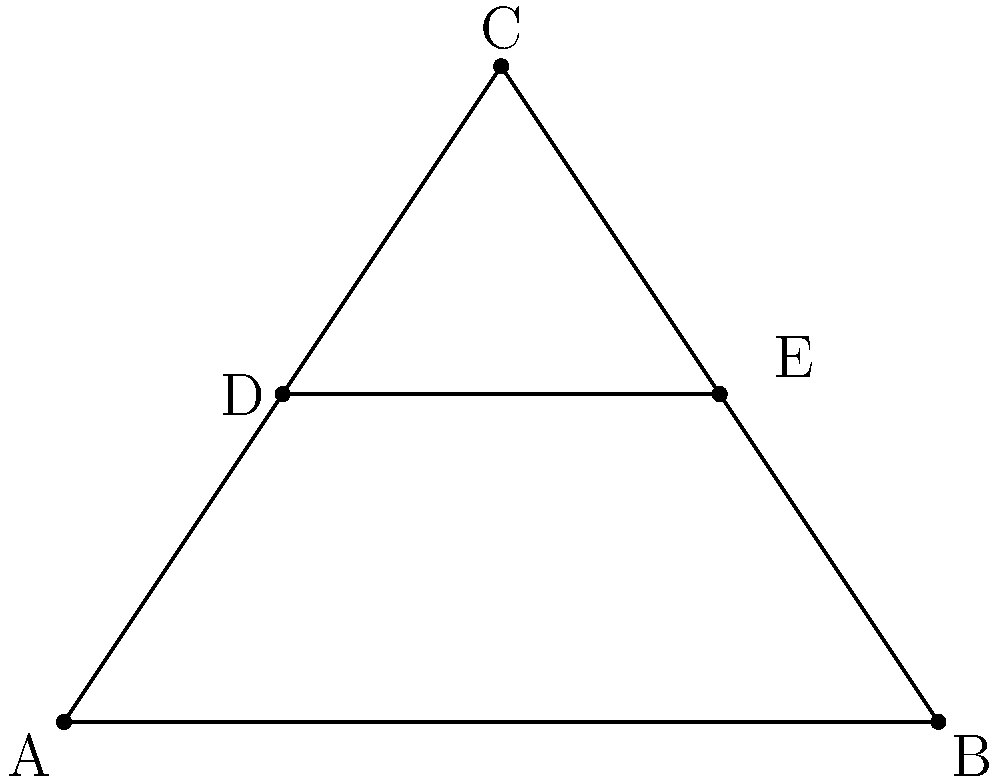In a fashion shoot, you're capturing a model wearing layered necklaces that form geometric patterns on her neckline. The necklaces create a triangle ABC with a straight line DE across it, as shown in the diagram. If the area of triangle ADE is 1.5 square inches and the area of triangle BDE is 2.25 square inches, what is the ratio of the length of AD to DB? Let's approach this step-by-step:

1) First, we know that the ratio of the areas of two triangles with the same height is equal to the ratio of their bases. In this case, the height is the perpendicular distance from point E to line AB.

2) Let's call the length of AD as x and the length of DB as y. So, AD:DB = x:y

3) The area of triangle ADE is proportional to x, and the area of triangle BDE is proportional to y.

4) We can set up the following proportion:
   $$\frac{\text{Area of ADE}}{\text{Area of BDE}} = \frac{x}{y}$$

5) Substituting the given areas:
   $$\frac{1.5}{2.25} = \frac{x}{y}$$

6) Simplifying:
   $$\frac{2}{3} = \frac{x}{y}$$

7) This means that AD:DB = 2:3

Therefore, the ratio of the length of AD to DB is 2:3.
Answer: 2:3 